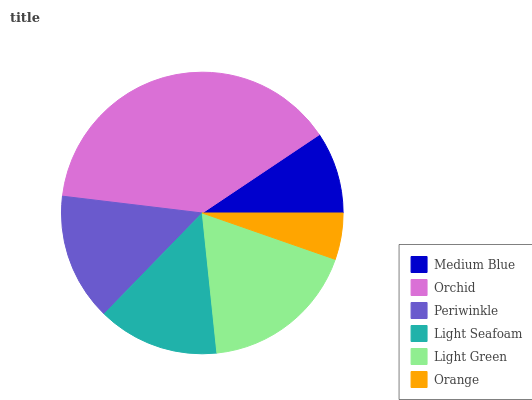Is Orange the minimum?
Answer yes or no. Yes. Is Orchid the maximum?
Answer yes or no. Yes. Is Periwinkle the minimum?
Answer yes or no. No. Is Periwinkle the maximum?
Answer yes or no. No. Is Orchid greater than Periwinkle?
Answer yes or no. Yes. Is Periwinkle less than Orchid?
Answer yes or no. Yes. Is Periwinkle greater than Orchid?
Answer yes or no. No. Is Orchid less than Periwinkle?
Answer yes or no. No. Is Periwinkle the high median?
Answer yes or no. Yes. Is Light Seafoam the low median?
Answer yes or no. Yes. Is Orchid the high median?
Answer yes or no. No. Is Medium Blue the low median?
Answer yes or no. No. 